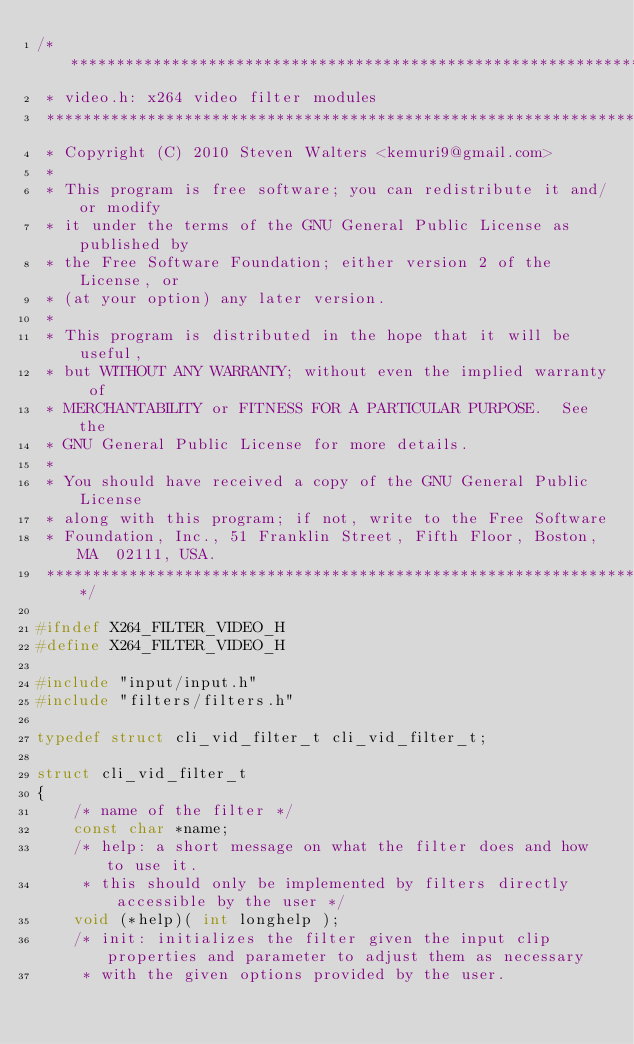Convert code to text. <code><loc_0><loc_0><loc_500><loc_500><_C_>/*****************************************************************************
 * video.h: x264 video filter modules
 *****************************************************************************
 * Copyright (C) 2010 Steven Walters <kemuri9@gmail.com>
 *
 * This program is free software; you can redistribute it and/or modify
 * it under the terms of the GNU General Public License as published by
 * the Free Software Foundation; either version 2 of the License, or
 * (at your option) any later version.
 *
 * This program is distributed in the hope that it will be useful,
 * but WITHOUT ANY WARRANTY; without even the implied warranty of
 * MERCHANTABILITY or FITNESS FOR A PARTICULAR PURPOSE.  See the
 * GNU General Public License for more details.
 *
 * You should have received a copy of the GNU General Public License
 * along with this program; if not, write to the Free Software
 * Foundation, Inc., 51 Franklin Street, Fifth Floor, Boston, MA  02111, USA.
 *****************************************************************************/

#ifndef X264_FILTER_VIDEO_H
#define X264_FILTER_VIDEO_H

#include "input/input.h"
#include "filters/filters.h"

typedef struct cli_vid_filter_t cli_vid_filter_t;

struct cli_vid_filter_t
{
    /* name of the filter */
    const char *name;
    /* help: a short message on what the filter does and how to use it.
     * this should only be implemented by filters directly accessible by the user */
    void (*help)( int longhelp );
    /* init: initializes the filter given the input clip properties and parameter to adjust them as necessary
     * with the given options provided by the user.</code> 